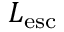Convert formula to latex. <formula><loc_0><loc_0><loc_500><loc_500>L _ { e s c }</formula> 